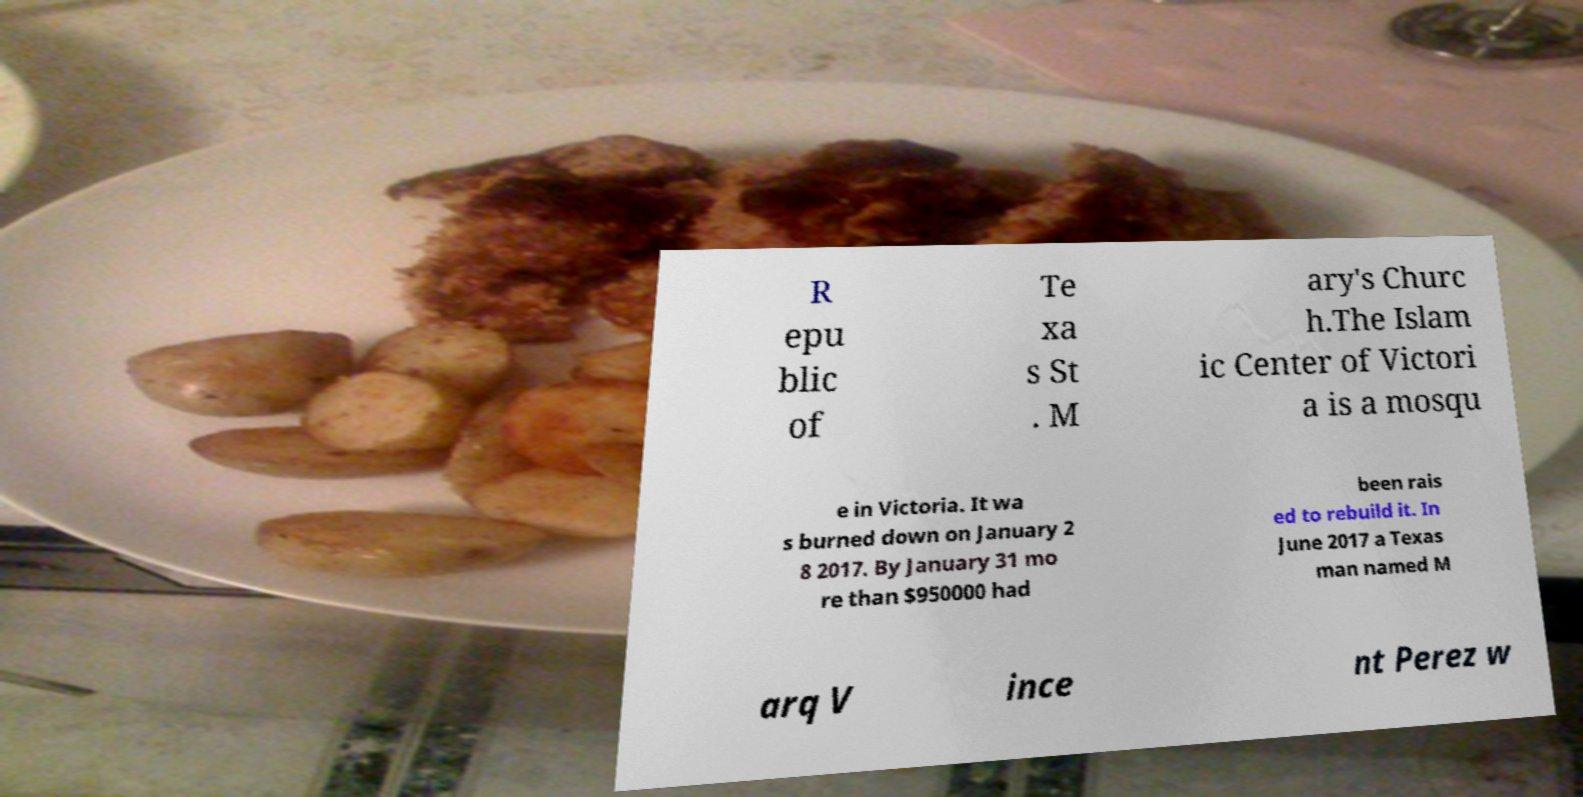I need the written content from this picture converted into text. Can you do that? R epu blic of Te xa s St . M ary's Churc h.The Islam ic Center of Victori a is a mosqu e in Victoria. It wa s burned down on January 2 8 2017. By January 31 mo re than $950000 had been rais ed to rebuild it. In June 2017 a Texas man named M arq V ince nt Perez w 